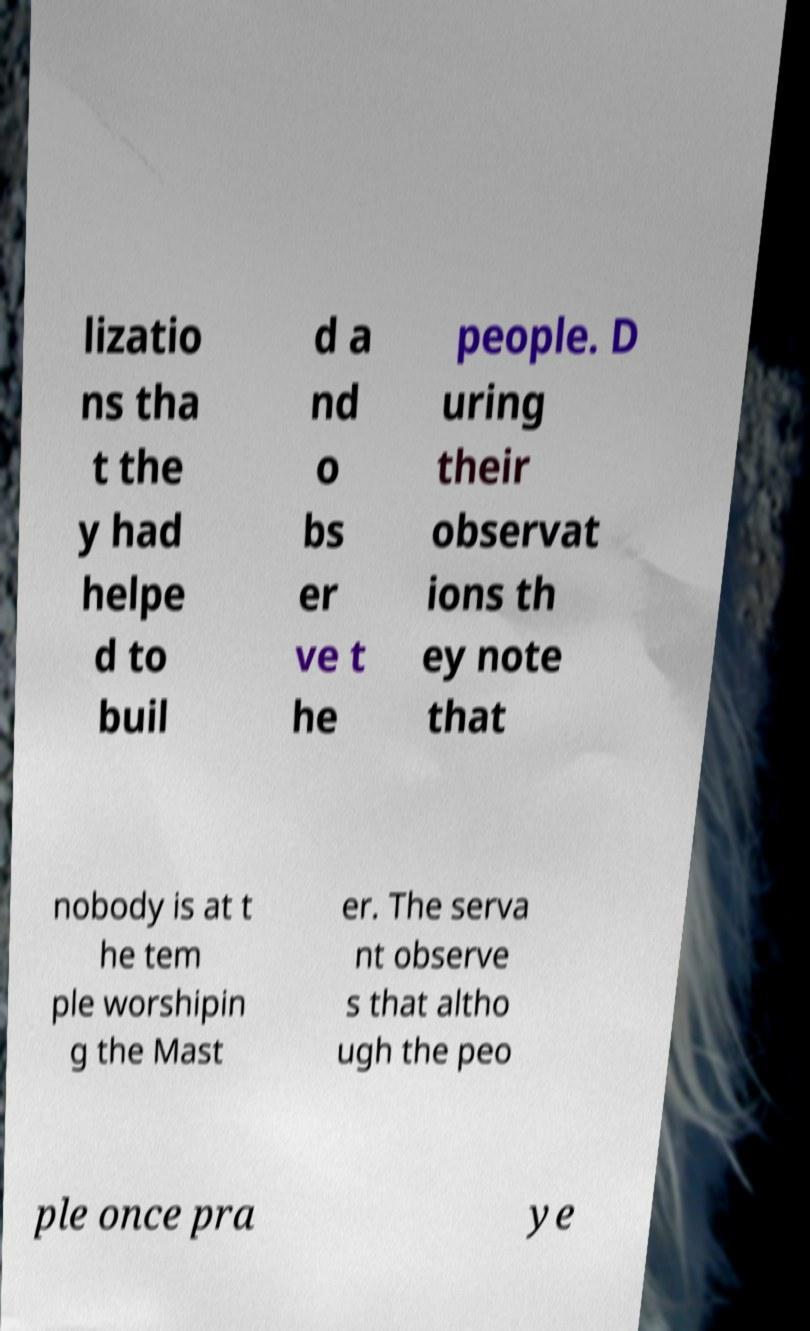I need the written content from this picture converted into text. Can you do that? lizatio ns tha t the y had helpe d to buil d a nd o bs er ve t he people. D uring their observat ions th ey note that nobody is at t he tem ple worshipin g the Mast er. The serva nt observe s that altho ugh the peo ple once pra ye 